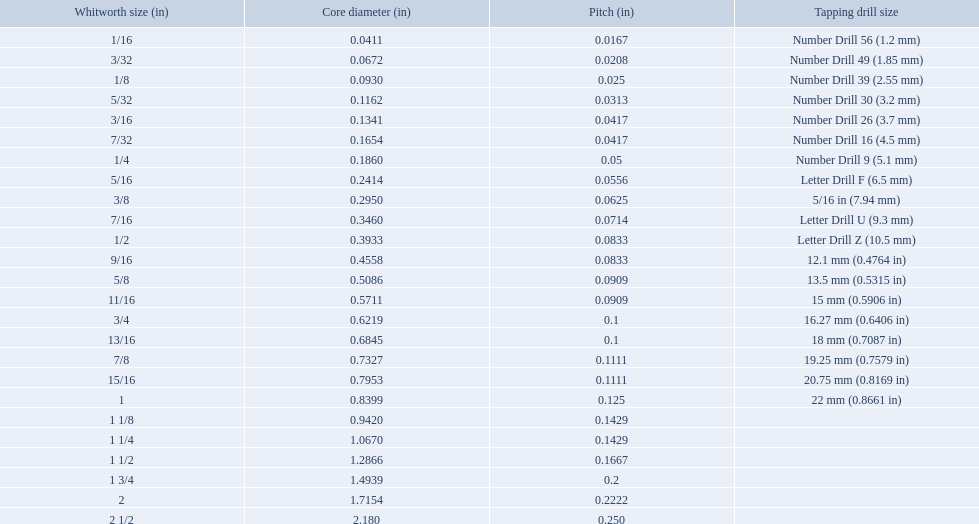A 1/16 whitworth has a core diameter of? 0.0411. Which whiteworth size has the same pitch as a 1/2? 9/16. 3/16 whiteworth has the same number of threads as? 7/32. What are the whitworth sizes? 1/16, 3/32, 1/8, 5/32, 3/16, 7/32, 1/4, 5/16, 3/8, 7/16, 1/2, 9/16, 5/8, 11/16, 3/4, 13/16, 7/8, 15/16, 1, 1 1/8, 1 1/4, 1 1/2, 1 3/4, 2, 2 1/2. And their threads per inch? 60, 48, 40, 32, 24, 24, 20, 18, 16, 14, 12, 12, 11, 11, 10, 10, 9, 9, 8, 7, 7, 6, 5, 4.5, 4. Now, which whitworth size has a thread-per-inch size of 5?? 1 3/4. What is the core diameter for the number drill 26? 0.1341. What is the whitworth size (in) for this core diameter? 3/16. What was the core diameter of a number drill 26 0.1341. What is this measurement in whitworth size? 3/16. 